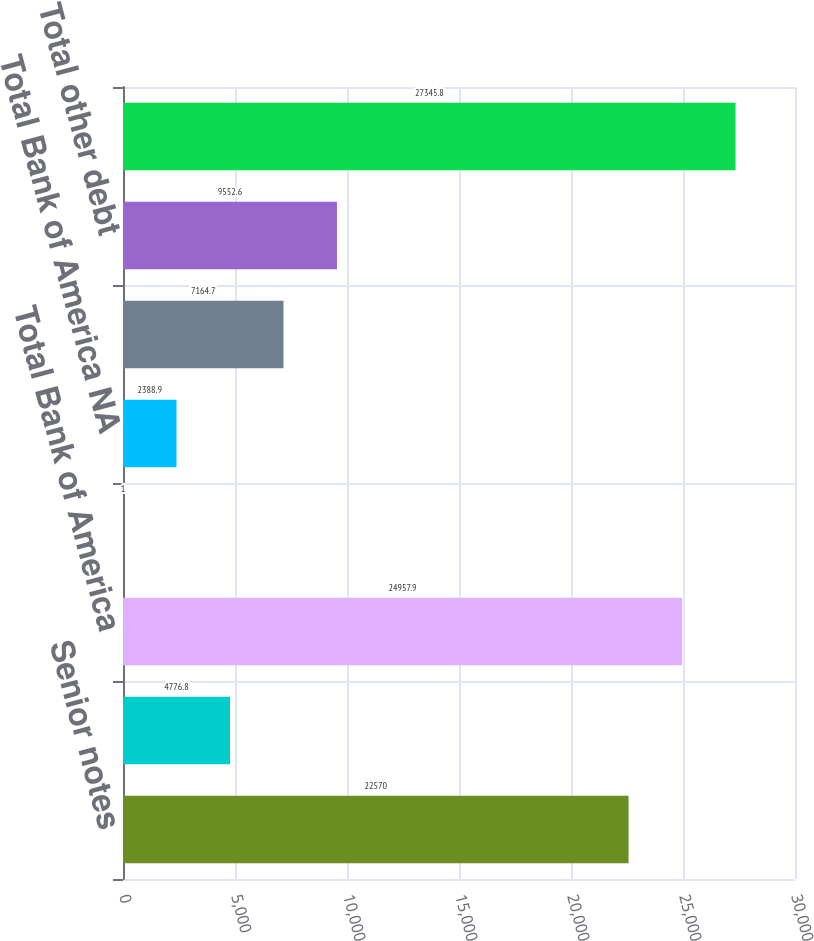Convert chart. <chart><loc_0><loc_0><loc_500><loc_500><bar_chart><fcel>Senior notes<fcel>Senior structured notes<fcel>Total Bank of America<fcel>Advances from Federal Home<fcel>Total Bank of America NA<fcel>Structured liabilities<fcel>Total other debt<fcel>Total long-term debt<nl><fcel>22570<fcel>4776.8<fcel>24957.9<fcel>1<fcel>2388.9<fcel>7164.7<fcel>9552.6<fcel>27345.8<nl></chart> 